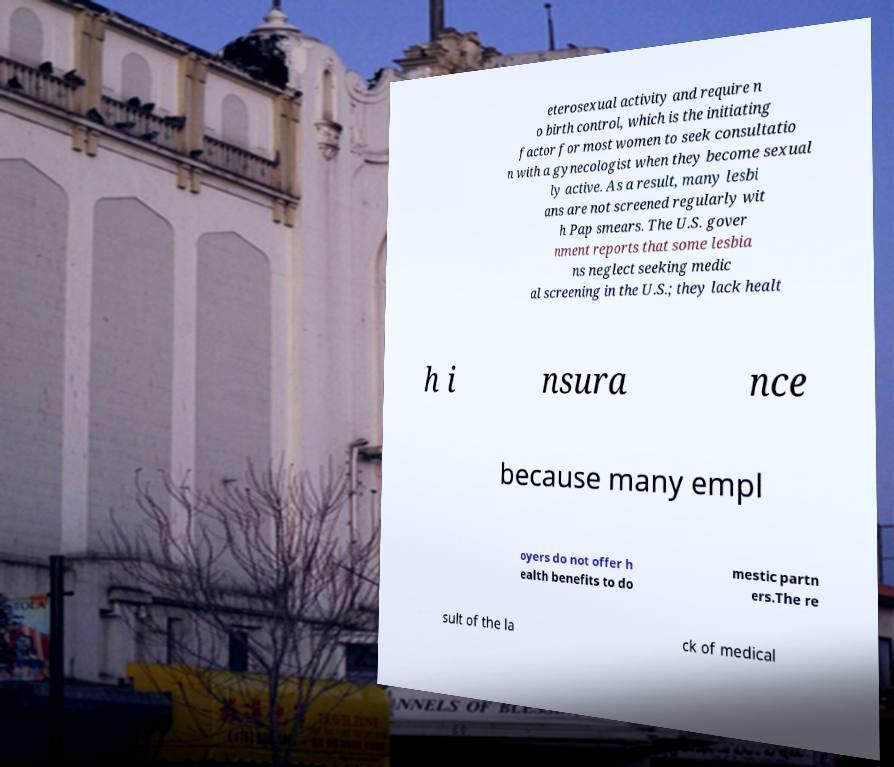Can you accurately transcribe the text from the provided image for me? eterosexual activity and require n o birth control, which is the initiating factor for most women to seek consultatio n with a gynecologist when they become sexual ly active. As a result, many lesbi ans are not screened regularly wit h Pap smears. The U.S. gover nment reports that some lesbia ns neglect seeking medic al screening in the U.S.; they lack healt h i nsura nce because many empl oyers do not offer h ealth benefits to do mestic partn ers.The re sult of the la ck of medical 